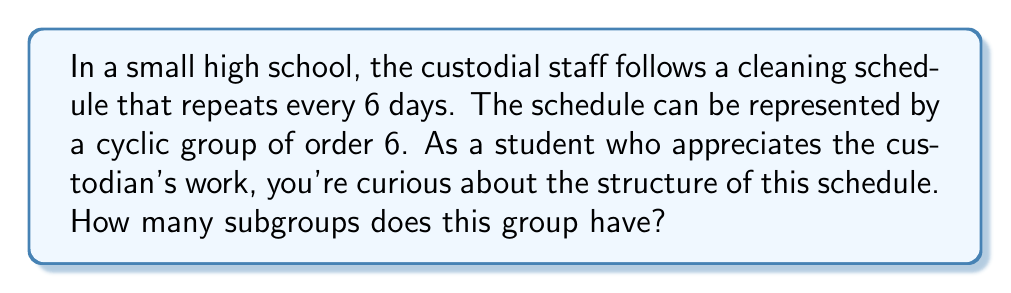Help me with this question. Let's approach this step-by-step:

1) First, we need to understand that the group in question is isomorphic to $C_6$, the cyclic group of order 6.

2) To find the number of subgroups, we need to consider the divisors of 6. The divisors of 6 are 1, 2, 3, and 6.

3) For each divisor $d$ of 6, there exists a unique subgroup of order $d$. This is a fundamental property of cyclic groups.

4) Let's list out these subgroups:
   - For $d=1$: The trivial subgroup $\{e\}$
   - For $d=2$: $\{e, r^3\}$, where $r$ is the generator of the group
   - For $d=3$: $\{e, r^2, r^4\}$
   - For $d=6$: The entire group $C_6$

5) We can verify this using Lagrange's theorem, which states that the order of a subgroup must divide the order of the group.

6) Therefore, the total number of subgroups is equal to the number of divisors of 6, which is 4.

This structure shows how the cleaning schedule can be broken down into shorter cycles (like 2-day or 3-day rotations) within the full 6-day schedule, which might be useful for organizing different cleaning tasks.
Answer: The cyclic group $C_6$, representing the custodial cleaning schedule, has 4 subgroups. 